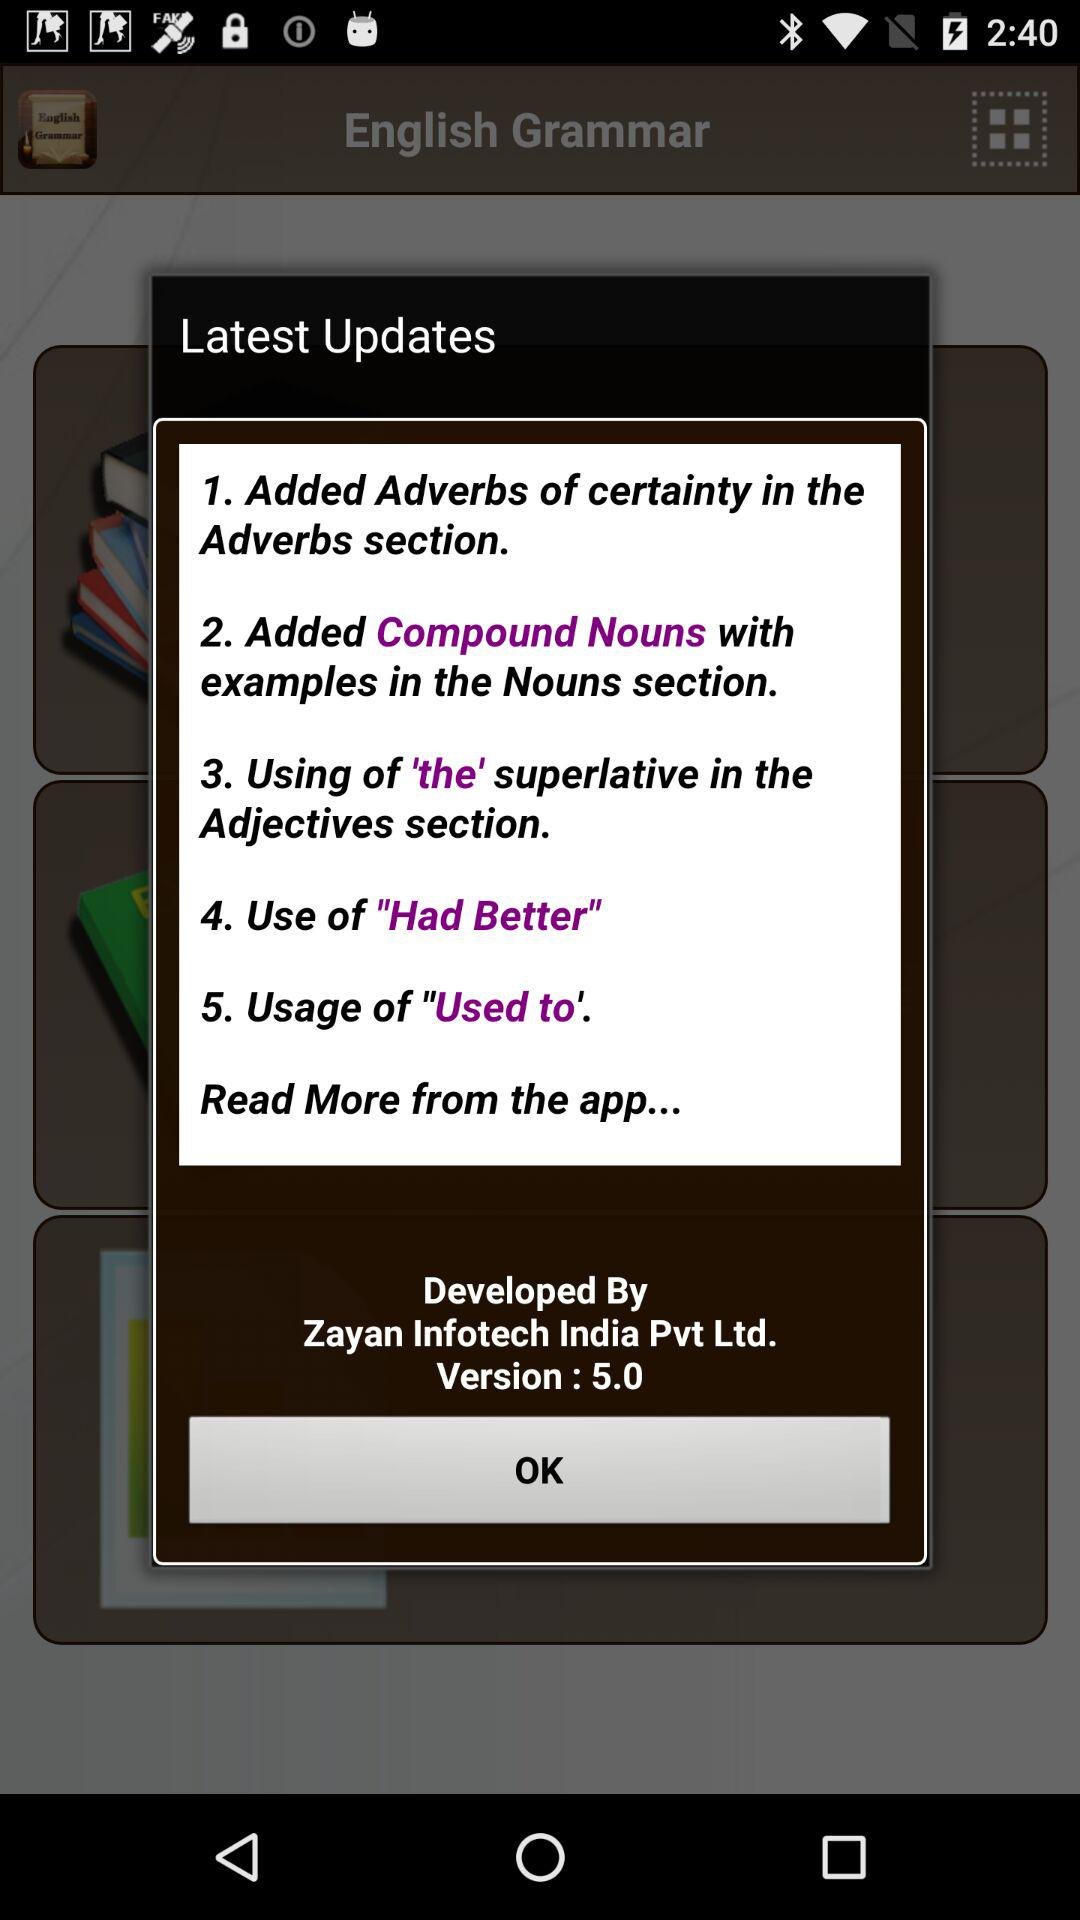Which version is this? The version is 5.0. 